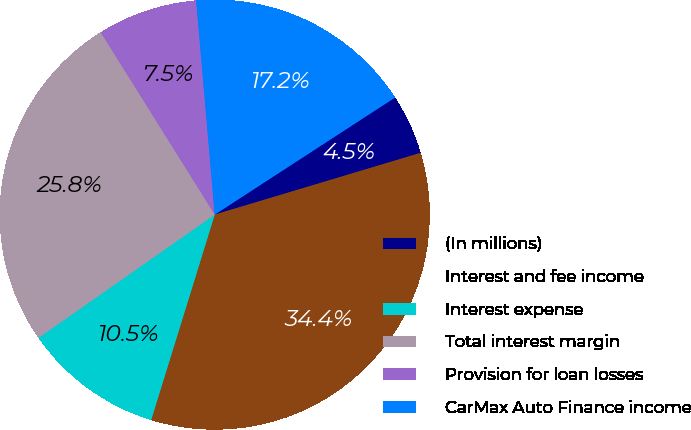Convert chart. <chart><loc_0><loc_0><loc_500><loc_500><pie_chart><fcel>(In millions)<fcel>Interest and fee income<fcel>Interest expense<fcel>Total interest margin<fcel>Provision for loan losses<fcel>CarMax Auto Finance income<nl><fcel>4.53%<fcel>34.42%<fcel>10.51%<fcel>25.82%<fcel>7.52%<fcel>17.21%<nl></chart> 